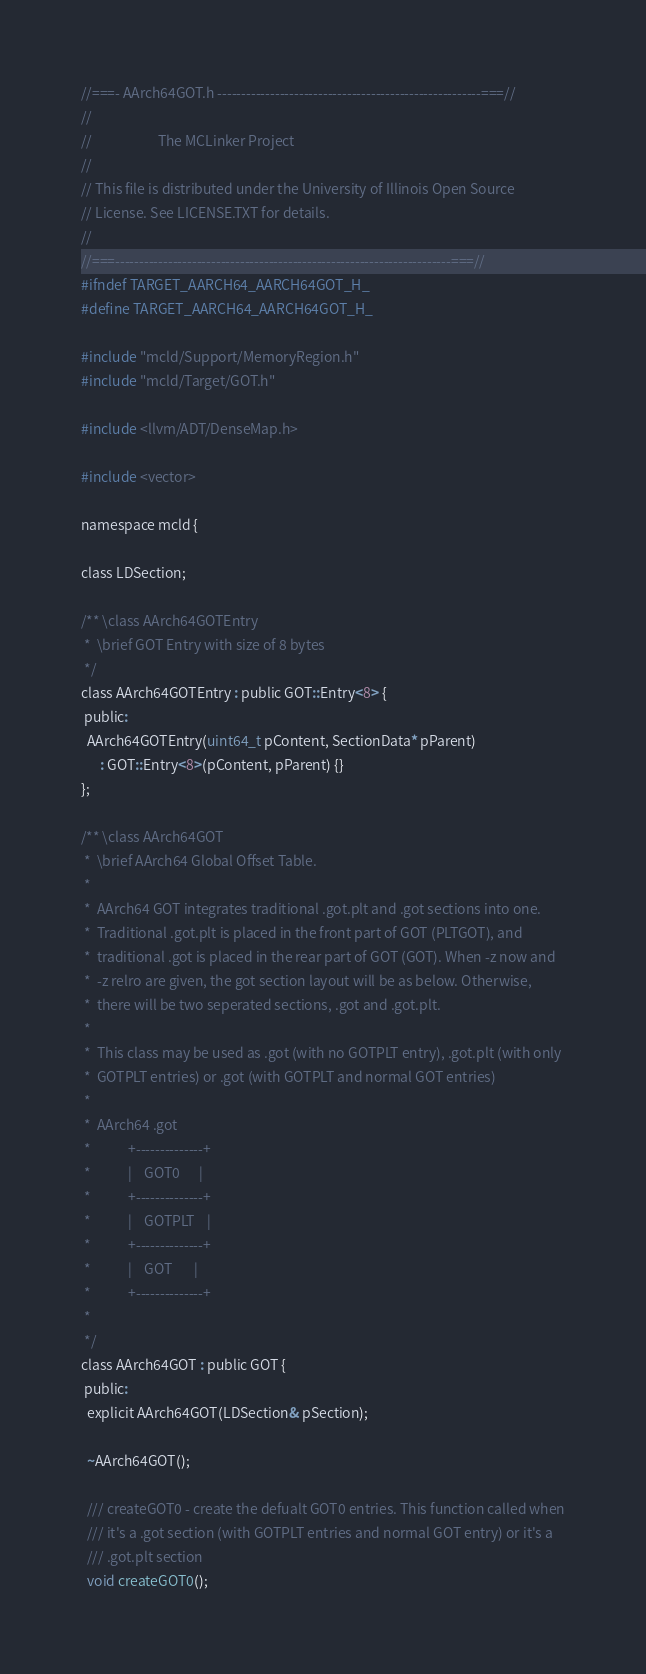<code> <loc_0><loc_0><loc_500><loc_500><_C_>//===- AArch64GOT.h -------------------------------------------------------===//
//
//                     The MCLinker Project
//
// This file is distributed under the University of Illinois Open Source
// License. See LICENSE.TXT for details.
//
//===----------------------------------------------------------------------===//
#ifndef TARGET_AARCH64_AARCH64GOT_H_
#define TARGET_AARCH64_AARCH64GOT_H_

#include "mcld/Support/MemoryRegion.h"
#include "mcld/Target/GOT.h"

#include <llvm/ADT/DenseMap.h>

#include <vector>

namespace mcld {

class LDSection;

/** \class AArch64GOTEntry
 *  \brief GOT Entry with size of 8 bytes
 */
class AArch64GOTEntry : public GOT::Entry<8> {
 public:
  AArch64GOTEntry(uint64_t pContent, SectionData* pParent)
      : GOT::Entry<8>(pContent, pParent) {}
};

/** \class AArch64GOT
 *  \brief AArch64 Global Offset Table.
 *
 *  AArch64 GOT integrates traditional .got.plt and .got sections into one.
 *  Traditional .got.plt is placed in the front part of GOT (PLTGOT), and
 *  traditional .got is placed in the rear part of GOT (GOT). When -z now and
 *  -z relro are given, the got section layout will be as below. Otherwise,
 *  there will be two seperated sections, .got and .got.plt.
 *
 *  This class may be used as .got (with no GOTPLT entry), .got.plt (with only
 *  GOTPLT entries) or .got (with GOTPLT and normal GOT entries)
 *
 *  AArch64 .got
 *            +--------------+
 *            |    GOT0      |
 *            +--------------+
 *            |    GOTPLT    |
 *            +--------------+
 *            |    GOT       |
 *            +--------------+
 *
 */
class AArch64GOT : public GOT {
 public:
  explicit AArch64GOT(LDSection& pSection);

  ~AArch64GOT();

  /// createGOT0 - create the defualt GOT0 entries. This function called when
  /// it's a .got section (with GOTPLT entries and normal GOT entry) or it's a
  /// .got.plt section
  void createGOT0();
</code> 